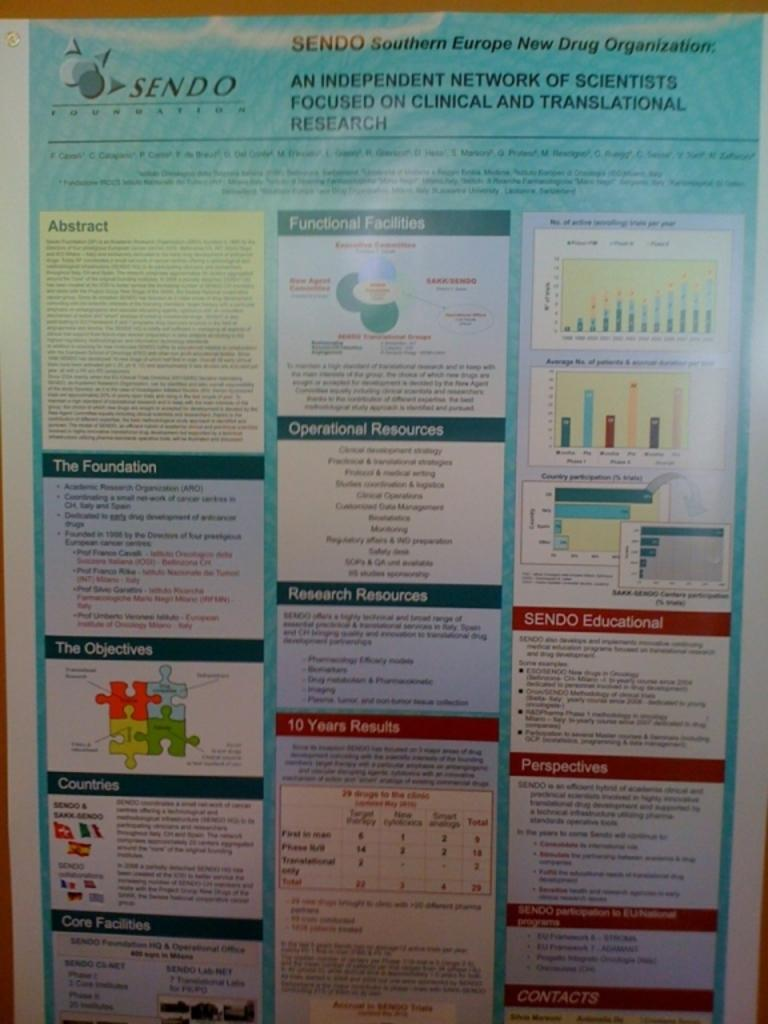<image>
Summarize the visual content of the image. A poster for SENDO shows several facts and charts on it. 